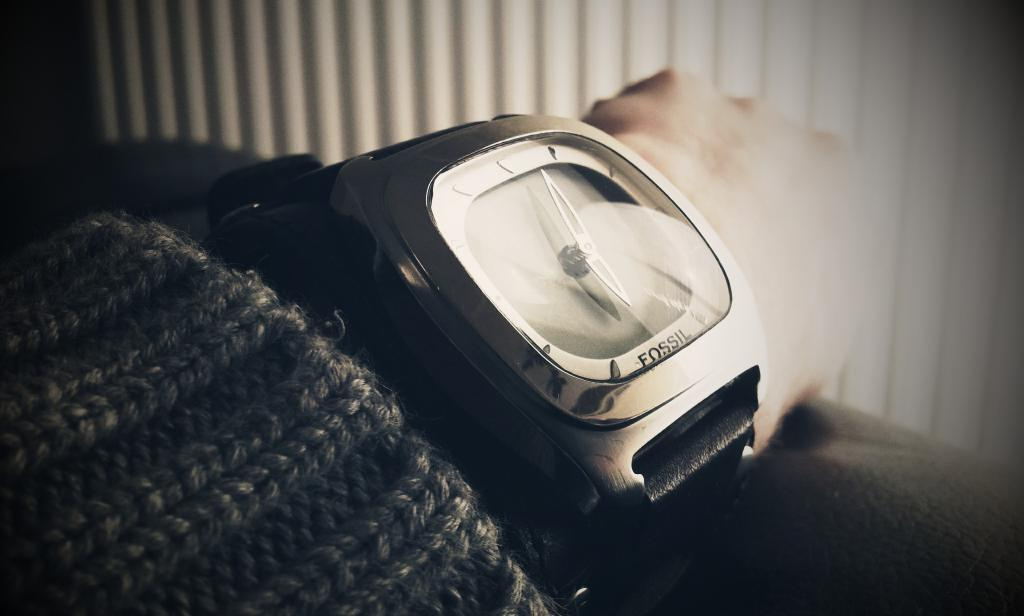Provide a one-sentence caption for the provided image. A watch, manufactured by Fossil, is on someone's wrist. 